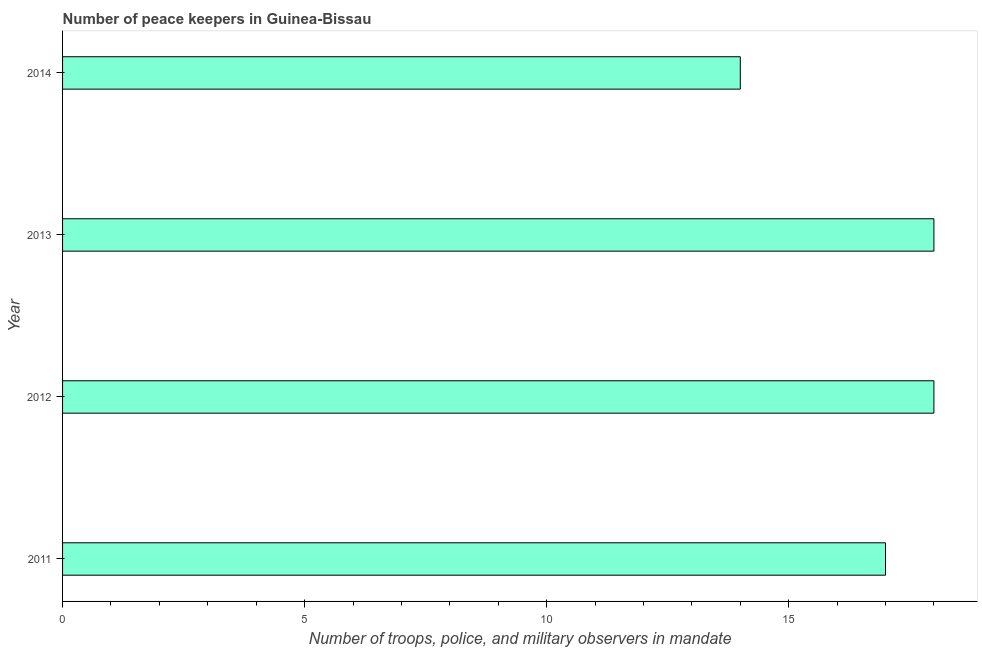Does the graph contain any zero values?
Keep it short and to the point. No. Does the graph contain grids?
Keep it short and to the point. No. What is the title of the graph?
Your answer should be compact. Number of peace keepers in Guinea-Bissau. What is the label or title of the X-axis?
Your response must be concise. Number of troops, police, and military observers in mandate. Across all years, what is the maximum number of peace keepers?
Your answer should be very brief. 18. In which year was the number of peace keepers minimum?
Offer a very short reply. 2014. What is the sum of the number of peace keepers?
Keep it short and to the point. 67. What is the difference between the number of peace keepers in 2012 and 2013?
Your response must be concise. 0. What is the median number of peace keepers?
Provide a succinct answer. 17.5. In how many years, is the number of peace keepers greater than 15 ?
Your response must be concise. 3. What is the ratio of the number of peace keepers in 2013 to that in 2014?
Your response must be concise. 1.29. Is the difference between the number of peace keepers in 2011 and 2012 greater than the difference between any two years?
Your response must be concise. No. Are all the bars in the graph horizontal?
Your answer should be very brief. Yes. How many years are there in the graph?
Your response must be concise. 4. What is the difference between two consecutive major ticks on the X-axis?
Your response must be concise. 5. Are the values on the major ticks of X-axis written in scientific E-notation?
Ensure brevity in your answer.  No. What is the Number of troops, police, and military observers in mandate of 2011?
Offer a very short reply. 17. What is the Number of troops, police, and military observers in mandate of 2013?
Provide a succinct answer. 18. What is the Number of troops, police, and military observers in mandate in 2014?
Make the answer very short. 14. What is the difference between the Number of troops, police, and military observers in mandate in 2011 and 2013?
Offer a terse response. -1. What is the difference between the Number of troops, police, and military observers in mandate in 2011 and 2014?
Your answer should be very brief. 3. What is the difference between the Number of troops, police, and military observers in mandate in 2012 and 2014?
Your answer should be compact. 4. What is the difference between the Number of troops, police, and military observers in mandate in 2013 and 2014?
Offer a very short reply. 4. What is the ratio of the Number of troops, police, and military observers in mandate in 2011 to that in 2012?
Your answer should be very brief. 0.94. What is the ratio of the Number of troops, police, and military observers in mandate in 2011 to that in 2013?
Give a very brief answer. 0.94. What is the ratio of the Number of troops, police, and military observers in mandate in 2011 to that in 2014?
Keep it short and to the point. 1.21. What is the ratio of the Number of troops, police, and military observers in mandate in 2012 to that in 2014?
Your response must be concise. 1.29. What is the ratio of the Number of troops, police, and military observers in mandate in 2013 to that in 2014?
Provide a succinct answer. 1.29. 